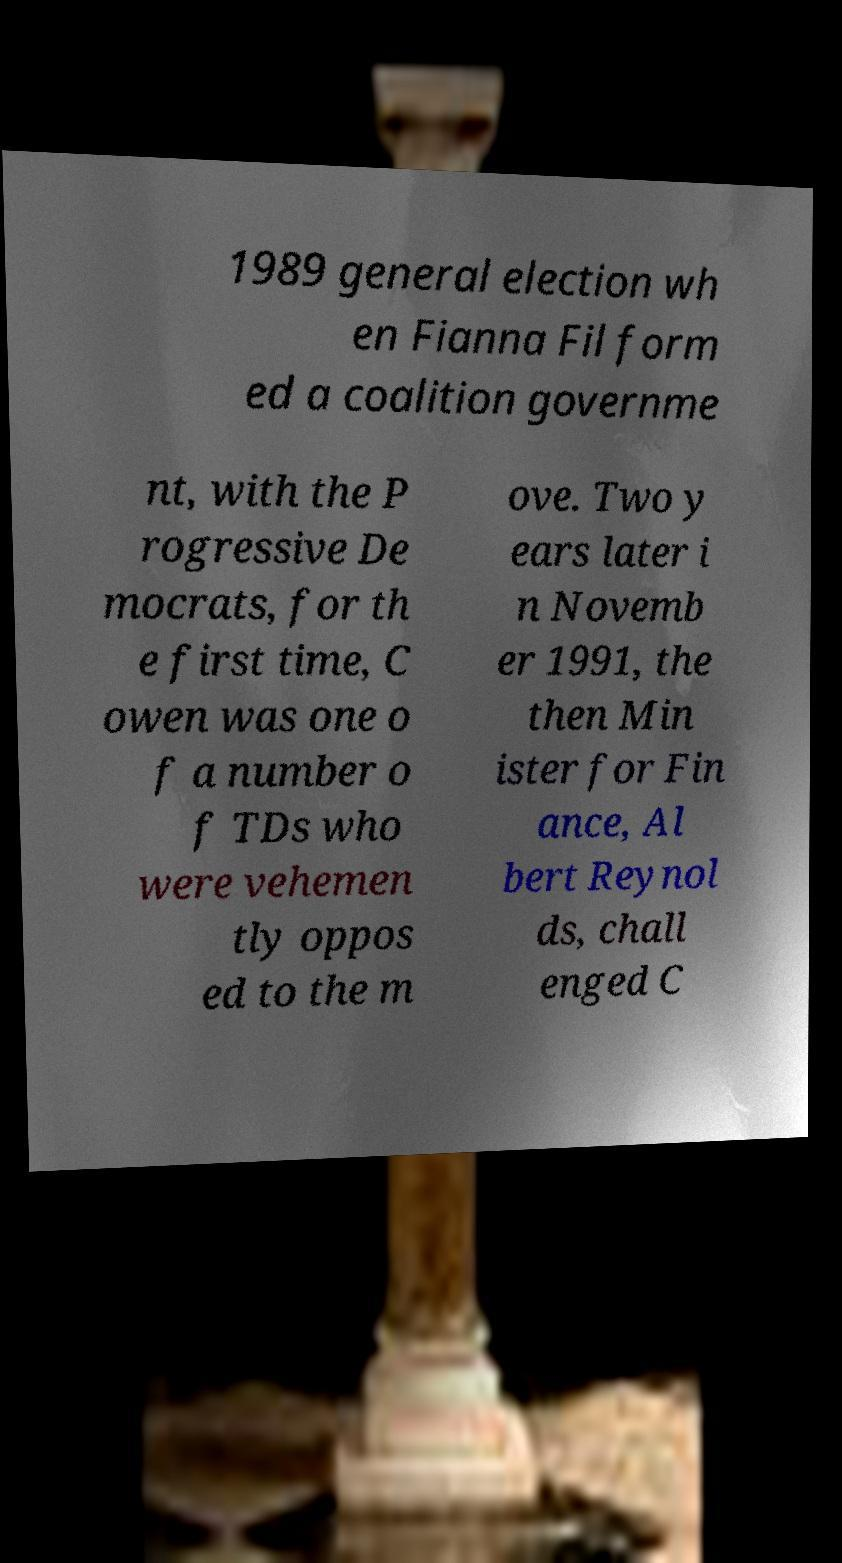There's text embedded in this image that I need extracted. Can you transcribe it verbatim? 1989 general election wh en Fianna Fil form ed a coalition governme nt, with the P rogressive De mocrats, for th e first time, C owen was one o f a number o f TDs who were vehemen tly oppos ed to the m ove. Two y ears later i n Novemb er 1991, the then Min ister for Fin ance, Al bert Reynol ds, chall enged C 